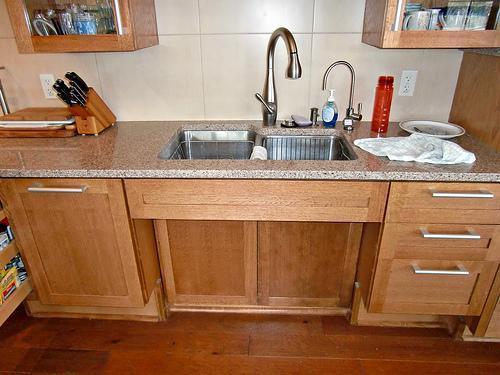How many plates are on the counter?
Give a very brief answer. 1. How many cabinet doors have glass fronts?
Give a very brief answer. 2. How many faucets are there?
Give a very brief answer. 2. 